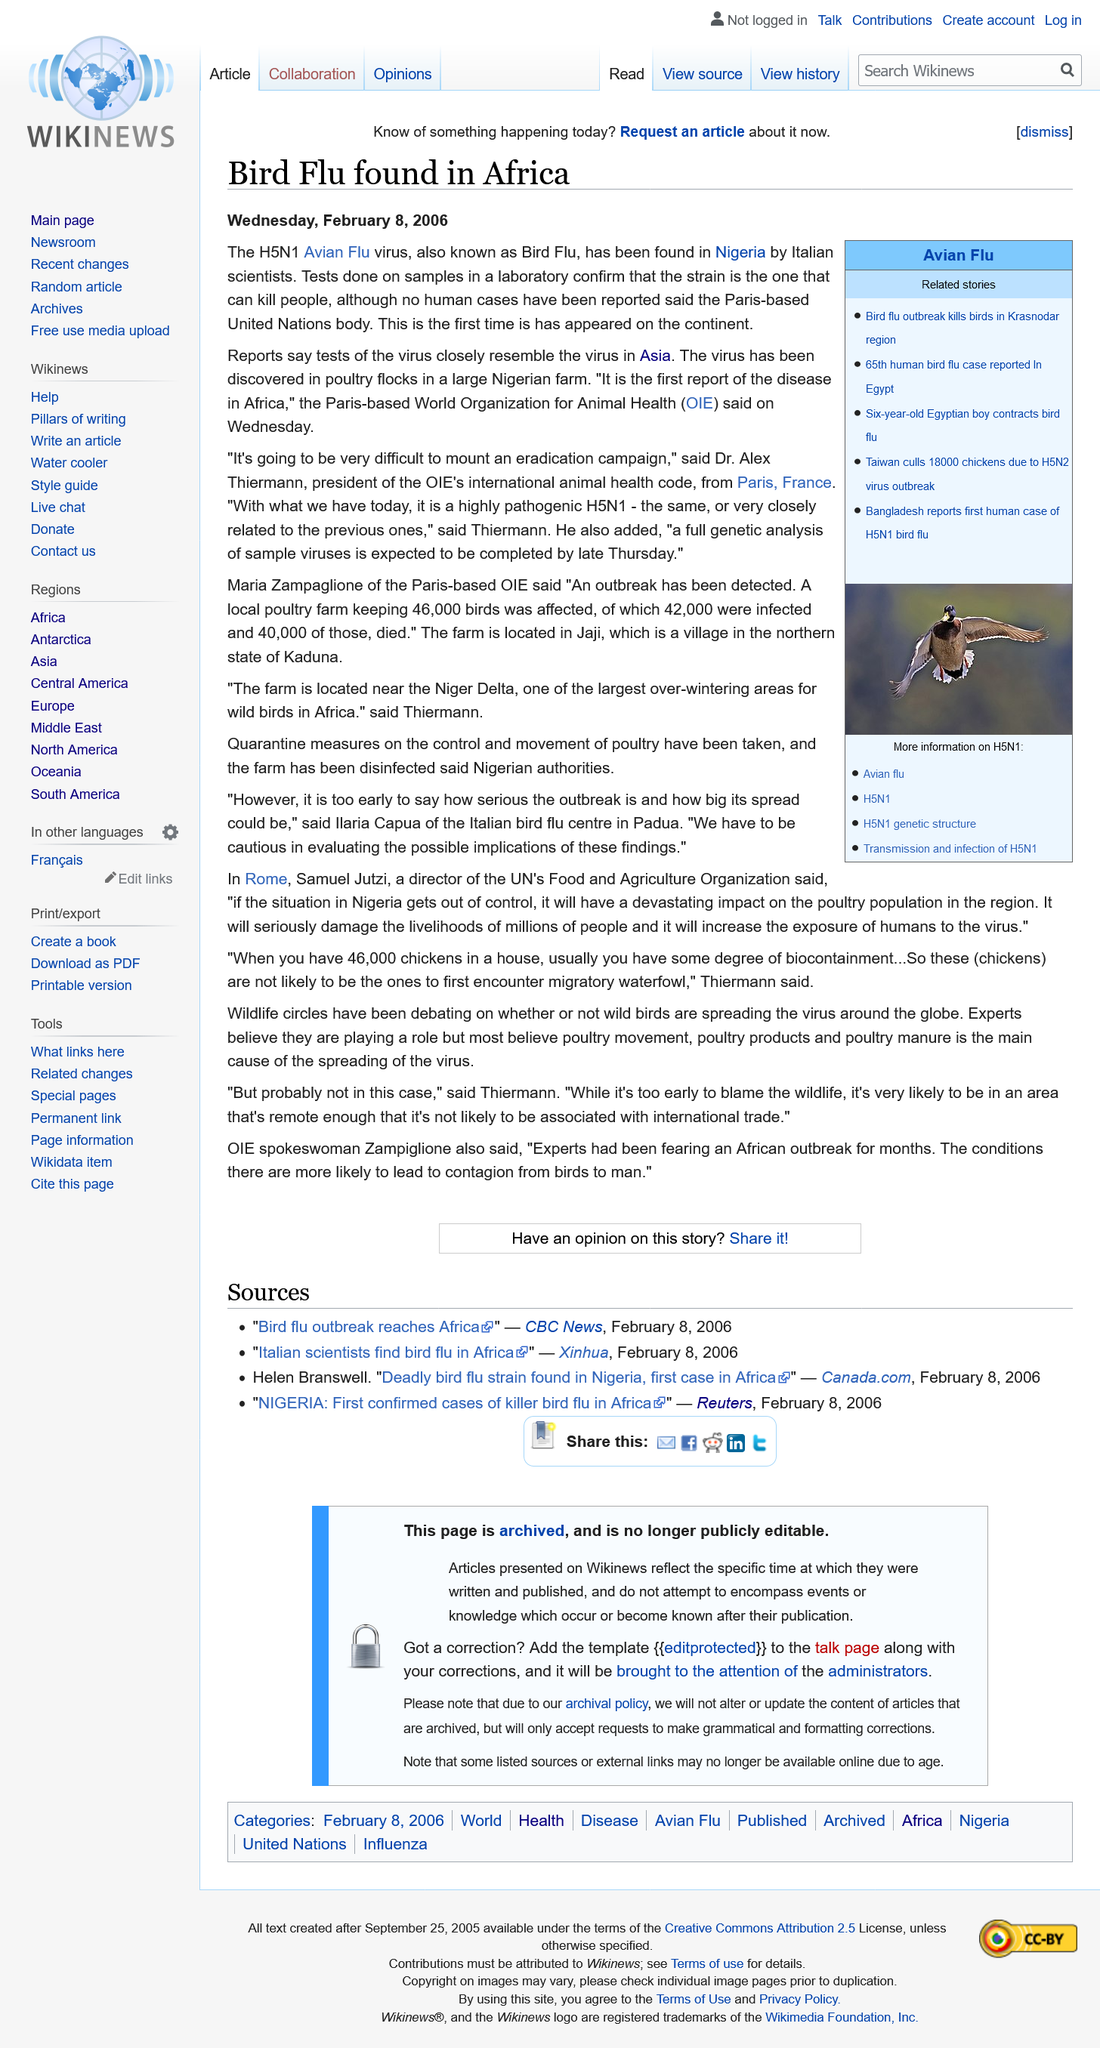Highlight a few significant elements in this photo. To date, there have been no confirmed cases of human infection with bird flu reported in the world. Bird flu has been detected in Nigeria, Africa, and other parts of the world, posing a significant public health threat. 